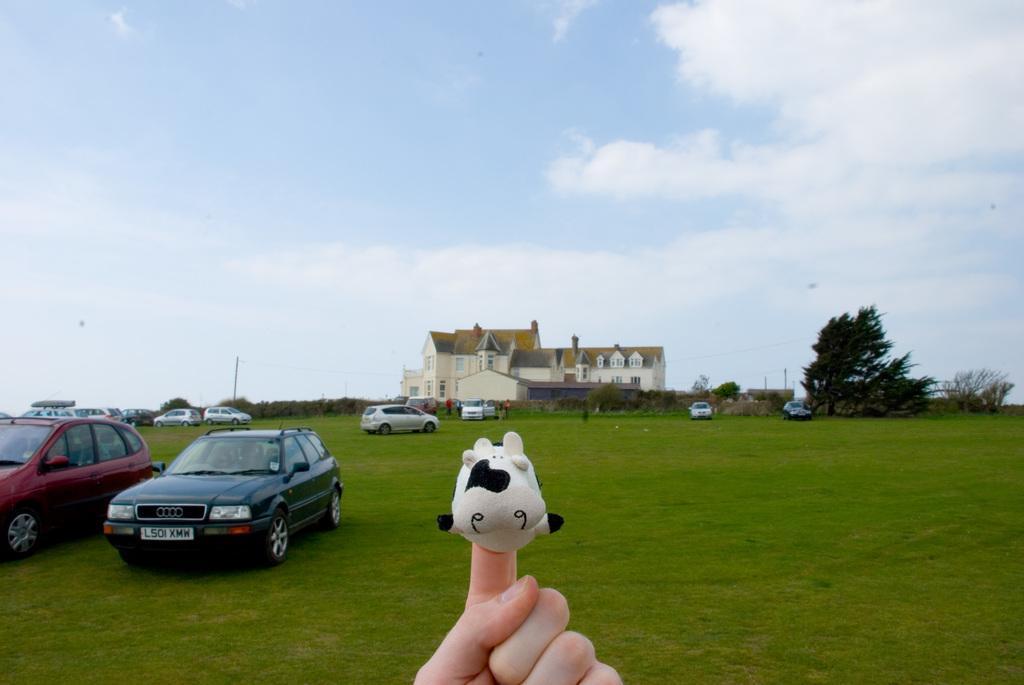How would you summarize this image in a sentence or two? In this image I can see a person's hand holding a toy, the toy is in white and black color, at the back I can see few vehicles. I can also see grass and trees in green color, building in cream color, at the top sky is in blue and white color. 